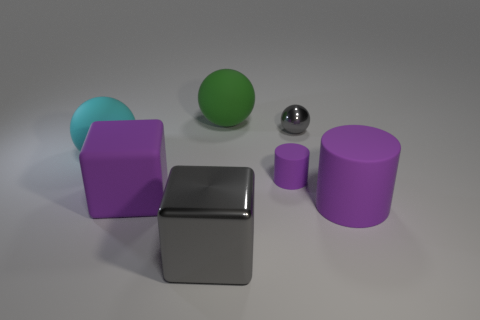Add 2 green matte spheres. How many objects exist? 9 Subtract all spheres. How many objects are left? 4 Add 7 small red rubber balls. How many small red rubber balls exist? 7 Subtract 0 green cylinders. How many objects are left? 7 Subtract all large matte objects. Subtract all purple matte things. How many objects are left? 0 Add 4 large spheres. How many large spheres are left? 6 